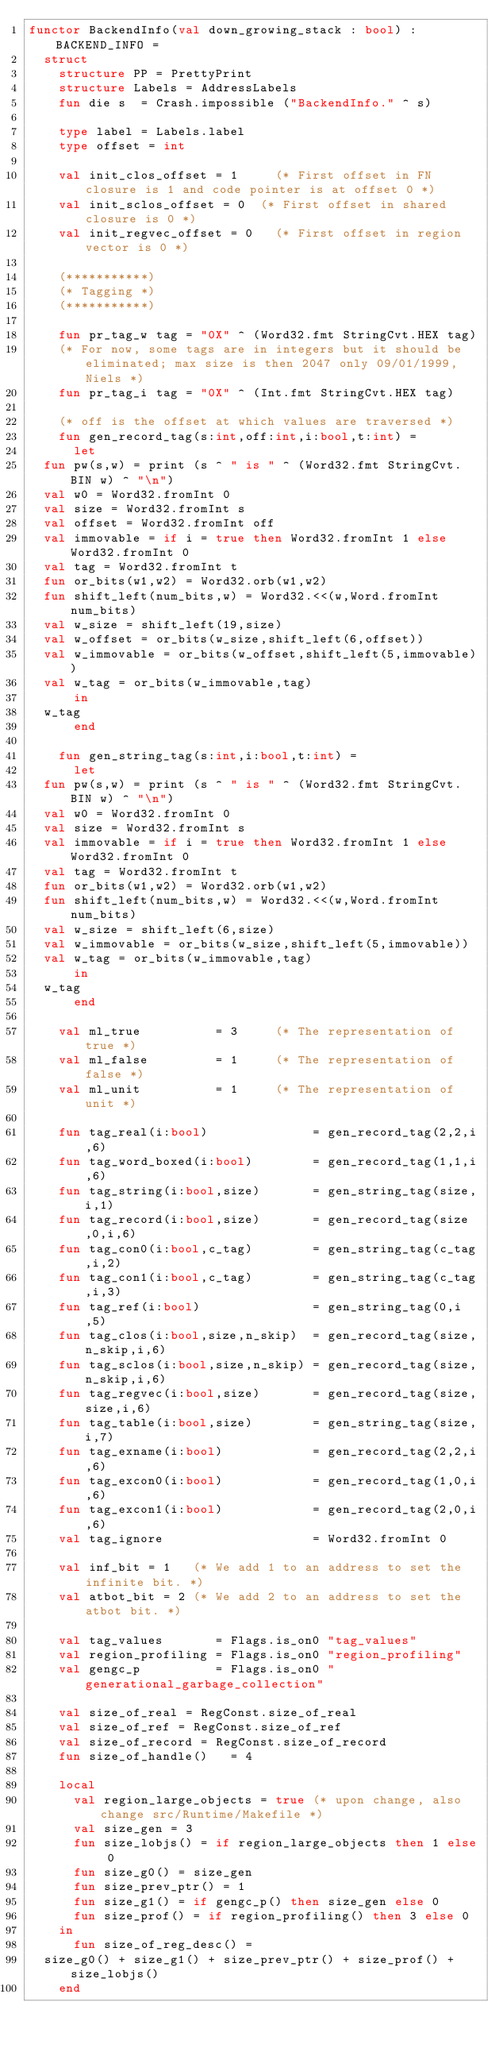Convert code to text. <code><loc_0><loc_0><loc_500><loc_500><_SML_>functor BackendInfo(val down_growing_stack : bool) : BACKEND_INFO =
  struct
    structure PP = PrettyPrint
    structure Labels = AddressLabels
    fun die s  = Crash.impossible ("BackendInfo." ^ s)

    type label = Labels.label
    type offset = int

    val init_clos_offset = 1     (* First offset in FN closure is 1 and code pointer is at offset 0 *) 
    val init_sclos_offset = 0	 (* First offset in shared closure is 0 *)                             
    val init_regvec_offset = 0	 (* First offset in region vector is 0 *)                              

    (***********)
    (* Tagging *)
    (***********)

    fun pr_tag_w tag = "0X" ^ (Word32.fmt StringCvt.HEX tag)
    (* For now, some tags are in integers but it should be eliminated; max size is then 2047 only 09/01/1999, Niels *)
    fun pr_tag_i tag = "0X" ^ (Int.fmt StringCvt.HEX tag)

    (* off is the offset at which values are traversed *)
    fun gen_record_tag(s:int,off:int,i:bool,t:int) = 
      let
	fun pw(s,w) = print (s ^ " is " ^ (Word32.fmt StringCvt.BIN w) ^ "\n")
	val w0 = Word32.fromInt 0
	val size = Word32.fromInt s
	val offset = Word32.fromInt off
	val immovable = if i = true then Word32.fromInt 1 else Word32.fromInt 0
	val tag = Word32.fromInt t
	fun or_bits(w1,w2) = Word32.orb(w1,w2)
	fun shift_left(num_bits,w) = Word32.<<(w,Word.fromInt num_bits)
	val w_size = shift_left(19,size)
	val w_offset = or_bits(w_size,shift_left(6,offset))
	val w_immovable = or_bits(w_offset,shift_left(5,immovable))
	val w_tag = or_bits(w_immovable,tag)
      in
	w_tag
      end

    fun gen_string_tag(s:int,i:bool,t:int) = 
      let
	fun pw(s,w) = print (s ^ " is " ^ (Word32.fmt StringCvt.BIN w) ^ "\n")
	val w0 = Word32.fromInt 0
	val size = Word32.fromInt s
	val immovable = if i = true then Word32.fromInt 1 else Word32.fromInt 0
	val tag = Word32.fromInt t
	fun or_bits(w1,w2) = Word32.orb(w1,w2)
	fun shift_left(num_bits,w) = Word32.<<(w,Word.fromInt num_bits)
	val w_size = shift_left(6,size)
	val w_immovable = or_bits(w_size,shift_left(5,immovable))
	val w_tag = or_bits(w_immovable,tag)
      in
	w_tag
      end

    val ml_true          = 3     (* The representation of true *)
    val ml_false         = 1     (* The representation of false *)
    val ml_unit          = 1     (* The representation of unit *)

    fun tag_real(i:bool)              = gen_record_tag(2,2,i,6)
    fun tag_word_boxed(i:bool)        = gen_record_tag(1,1,i,6)
    fun tag_string(i:bool,size)       = gen_string_tag(size,i,1)
    fun tag_record(i:bool,size)       = gen_record_tag(size,0,i,6)
    fun tag_con0(i:bool,c_tag)        = gen_string_tag(c_tag,i,2)
    fun tag_con1(i:bool,c_tag)        = gen_string_tag(c_tag,i,3)
    fun tag_ref(i:bool)               = gen_string_tag(0,i,5)
    fun tag_clos(i:bool,size,n_skip)  = gen_record_tag(size,n_skip,i,6)
    fun tag_sclos(i:bool,size,n_skip) = gen_record_tag(size,n_skip,i,6)
    fun tag_regvec(i:bool,size)       = gen_record_tag(size,size,i,6)
    fun tag_table(i:bool,size)        = gen_string_tag(size,i,7)
    fun tag_exname(i:bool)            = gen_record_tag(2,2,i,6)
    fun tag_excon0(i:bool)            = gen_record_tag(1,0,i,6)
    fun tag_excon1(i:bool)            = gen_record_tag(2,0,i,6)
    val tag_ignore                    = Word32.fromInt 0

    val inf_bit = 1   (* We add 1 to an address to set the infinite bit. *)
    val atbot_bit = 2 (* We add 2 to an address to set the atbot bit. *)

    val tag_values       = Flags.is_on0 "tag_values"
    val region_profiling = Flags.is_on0 "region_profiling"
    val gengc_p          = Flags.is_on0 "generational_garbage_collection"

    val size_of_real = RegConst.size_of_real
    val size_of_ref = RegConst.size_of_ref
    val size_of_record = RegConst.size_of_record
    fun size_of_handle()   = 4

    local
      val region_large_objects = true (* upon change, also change src/Runtime/Makefile *)
      val size_gen = 3
      fun size_lobjs() = if region_large_objects then 1 else 0
      fun size_g0() = size_gen
      fun size_prev_ptr() = 1
      fun size_g1() = if gengc_p() then size_gen else 0
      fun size_prof() = if region_profiling() then 3 else 0
    in
      fun size_of_reg_desc() = 
	size_g0() + size_g1() + size_prev_ptr() + size_prof() + size_lobjs()
    end
</code> 